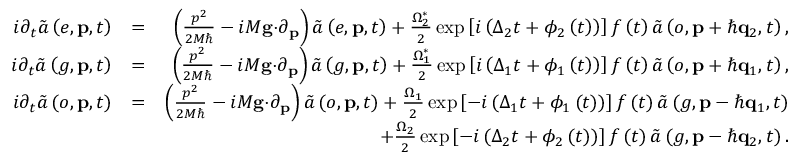Convert formula to latex. <formula><loc_0><loc_0><loc_500><loc_500>\begin{array} { r l r } { i \partial _ { t } \tilde { a } \left ( e , p , t \right ) } & { = } & { \left ( \frac { p ^ { 2 } } { 2 M } - i M g \cdot \partial _ { p } \right ) \tilde { a } \left ( e , p , t \right ) + \frac { \Omega _ { 2 } ^ { \ast } } { 2 } \exp \left [ i \left ( \Delta _ { 2 } t + \phi _ { 2 } \left ( t \right ) \right ) \right ] f \left ( t \right ) \tilde { a } \left ( o , p + \hbar { q } _ { 2 } , t \right ) , } \\ { i \partial _ { t } \tilde { a } \left ( g , p , t \right ) } & { = } & { \left ( \frac { p ^ { 2 } } { 2 M } - i M g \cdot \partial _ { p } \right ) \tilde { a } \left ( g , p , t \right ) + \frac { \Omega _ { 1 } ^ { \ast } } { 2 } \exp \left [ i \left ( \Delta _ { 1 } t + \phi _ { 1 } \left ( t \right ) \right ) \right ] f \left ( t \right ) \tilde { a } \left ( o , p + \hbar { q } _ { 1 } , t \right ) , } \\ { i \partial _ { t } \tilde { a } \left ( o , p , t \right ) } & { = } & { \left ( \frac { p ^ { 2 } } { 2 M } - i M g \cdot \partial _ { p } \right ) \tilde { a } \left ( o , p , t \right ) + \frac { \Omega _ { 1 } } { 2 } \exp \left [ - i \left ( \Delta _ { 1 } t + \phi _ { 1 } \left ( t \right ) \right ) \right ] f \left ( t \right ) \tilde { a } \left ( g , p - \hbar { q } _ { 1 } , t \right ) } \\ & { + \frac { \Omega _ { 2 } } { 2 } \exp \left [ - i \left ( \Delta _ { 2 } t + \phi _ { 2 } \left ( t \right ) \right ) \right ] f \left ( t \right ) \tilde { a } \left ( g , p - \hbar { q } _ { 2 } , t \right ) . } \end{array}</formula> 